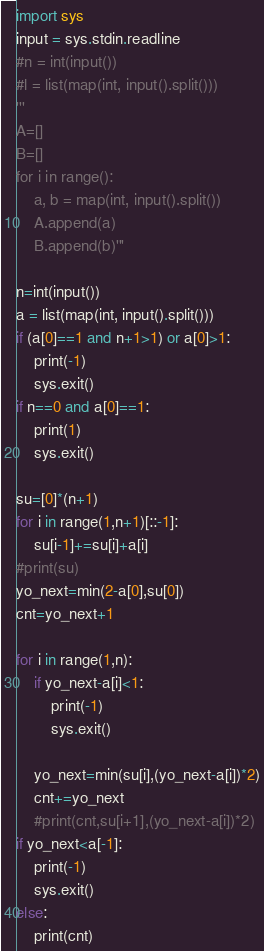Convert code to text. <code><loc_0><loc_0><loc_500><loc_500><_Python_>import sys
input = sys.stdin.readline
#n = int(input())
#l = list(map(int, input().split()))
'''
A=[]
B=[]
for i in range():
    a, b = map(int, input().split())
    A.append(a)
    B.append(b)'''

n=int(input())
a = list(map(int, input().split()))
if (a[0]==1 and n+1>1) or a[0]>1:
    print(-1)
    sys.exit()
if n==0 and a[0]==1:
    print(1)
    sys.exit()

su=[0]*(n+1)
for i in range(1,n+1)[::-1]:
    su[i-1]+=su[i]+a[i]
#print(su)
yo_next=min(2-a[0],su[0])
cnt=yo_next+1

for i in range(1,n):
    if yo_next-a[i]<1:
        print(-1)
        sys.exit()
    
    yo_next=min(su[i],(yo_next-a[i])*2)
    cnt+=yo_next
    #print(cnt,su[i+1],(yo_next-a[i])*2)
if yo_next<a[-1]:
    print(-1)
    sys.exit()
else:
    print(cnt)</code> 